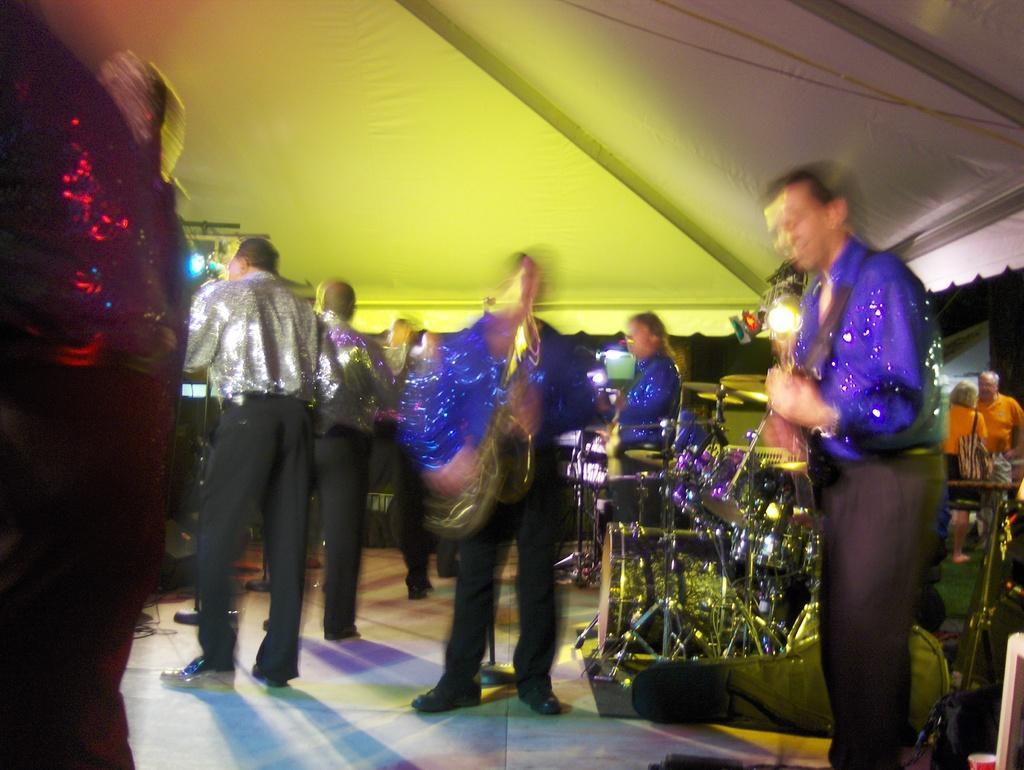Can you describe this image briefly? In this image we can see a few people standing, we can see musical instruments, at the top we can see shed and led lights. 